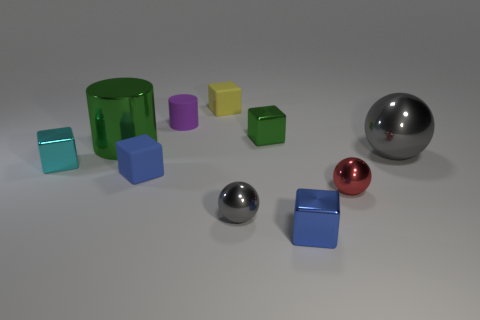There is a small green cube; are there any small cyan blocks left of it?
Your response must be concise. Yes. What is the material of the small cyan block?
Offer a terse response. Metal. What shape is the purple rubber object that is behind the small cyan cube?
Your answer should be compact. Cylinder. Are there any cylinders of the same size as the green metal block?
Provide a short and direct response. Yes. Is the material of the cylinder that is behind the small green metal block the same as the cyan object?
Offer a terse response. No. Are there the same number of tiny shiny cubes left of the small cyan cube and tiny matte objects on the left side of the small purple rubber object?
Your answer should be compact. No. The tiny shiny thing that is both behind the red shiny sphere and in front of the tiny green object has what shape?
Offer a terse response. Cube. What number of gray metal objects are behind the tiny red ball?
Keep it short and to the point. 1. What number of other objects are the same shape as the tiny green thing?
Ensure brevity in your answer.  4. Are there fewer cyan metal cubes than green metal things?
Provide a short and direct response. Yes. 